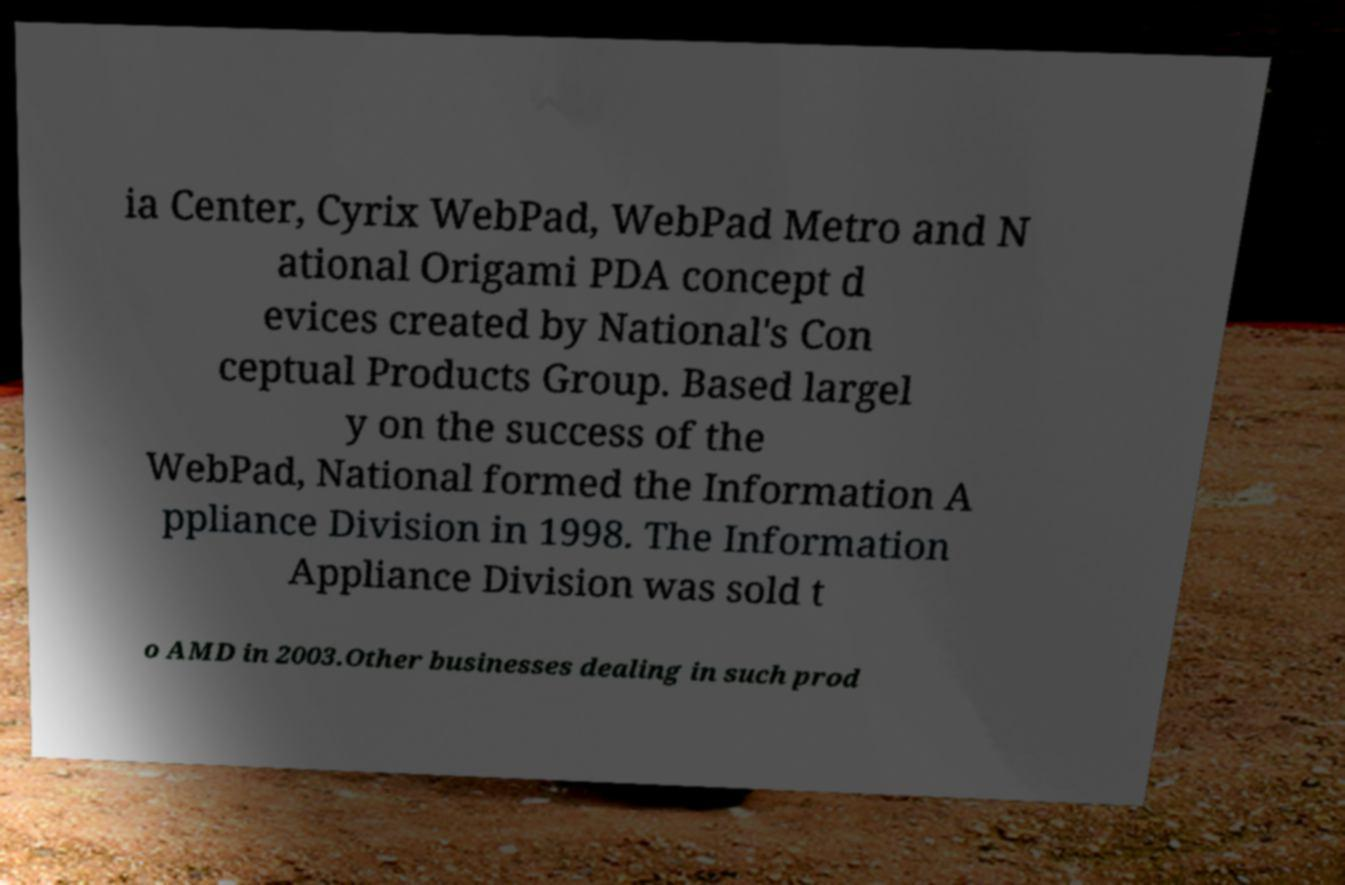There's text embedded in this image that I need extracted. Can you transcribe it verbatim? ia Center, Cyrix WebPad, WebPad Metro and N ational Origami PDA concept d evices created by National's Con ceptual Products Group. Based largel y on the success of the WebPad, National formed the Information A ppliance Division in 1998. The Information Appliance Division was sold t o AMD in 2003.Other businesses dealing in such prod 